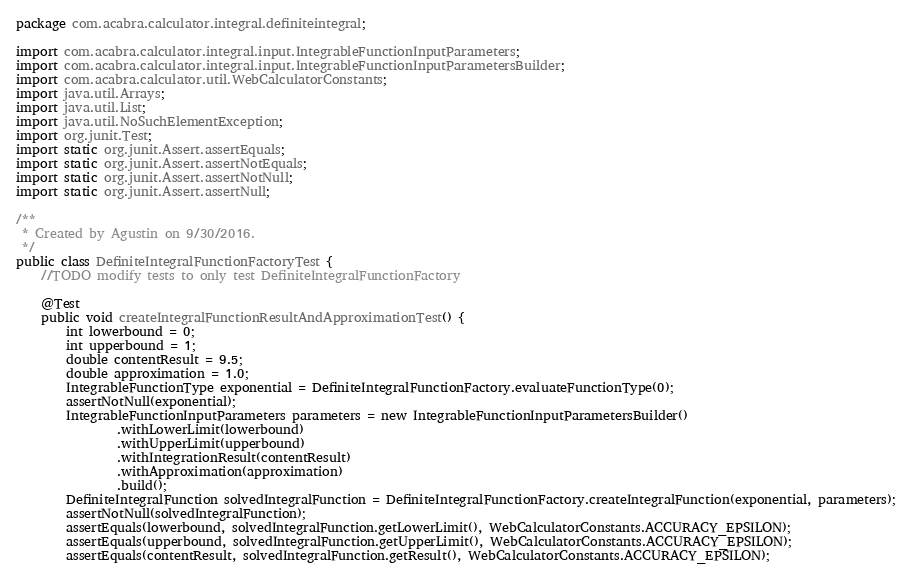Convert code to text. <code><loc_0><loc_0><loc_500><loc_500><_Java_>package com.acabra.calculator.integral.definiteintegral;

import com.acabra.calculator.integral.input.IntegrableFunctionInputParameters;
import com.acabra.calculator.integral.input.IntegrableFunctionInputParametersBuilder;
import com.acabra.calculator.util.WebCalculatorConstants;
import java.util.Arrays;
import java.util.List;
import java.util.NoSuchElementException;
import org.junit.Test;
import static org.junit.Assert.assertEquals;
import static org.junit.Assert.assertNotEquals;
import static org.junit.Assert.assertNotNull;
import static org.junit.Assert.assertNull;

/**
 * Created by Agustin on 9/30/2016.
 */
public class DefiniteIntegralFunctionFactoryTest {
    //TODO modify tests to only test DefiniteIntegralFunctionFactory

    @Test
    public void createIntegralFunctionResultAndApproximationTest() {
        int lowerbound = 0;
        int upperbound = 1;
        double contentResult = 9.5;
        double approximation = 1.0;
        IntegrableFunctionType exponential = DefiniteIntegralFunctionFactory.evaluateFunctionType(0);
        assertNotNull(exponential);
        IntegrableFunctionInputParameters parameters = new IntegrableFunctionInputParametersBuilder()
                .withLowerLimit(lowerbound)
                .withUpperLimit(upperbound)
                .withIntegrationResult(contentResult)
                .withApproximation(approximation)
                .build();
        DefiniteIntegralFunction solvedIntegralFunction = DefiniteIntegralFunctionFactory.createIntegralFunction(exponential, parameters);
        assertNotNull(solvedIntegralFunction);
        assertEquals(lowerbound, solvedIntegralFunction.getLowerLimit(), WebCalculatorConstants.ACCURACY_EPSILON);
        assertEquals(upperbound, solvedIntegralFunction.getUpperLimit(), WebCalculatorConstants.ACCURACY_EPSILON);
        assertEquals(contentResult, solvedIntegralFunction.getResult(), WebCalculatorConstants.ACCURACY_EPSILON);</code> 